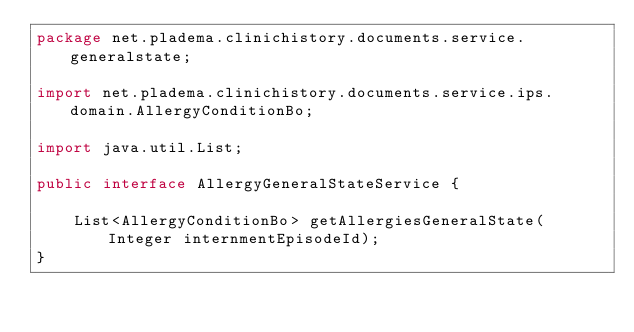<code> <loc_0><loc_0><loc_500><loc_500><_Java_>package net.pladema.clinichistory.documents.service.generalstate;

import net.pladema.clinichistory.documents.service.ips.domain.AllergyConditionBo;

import java.util.List;

public interface AllergyGeneralStateService {

    List<AllergyConditionBo> getAllergiesGeneralState(Integer internmentEpisodeId);
}
</code> 